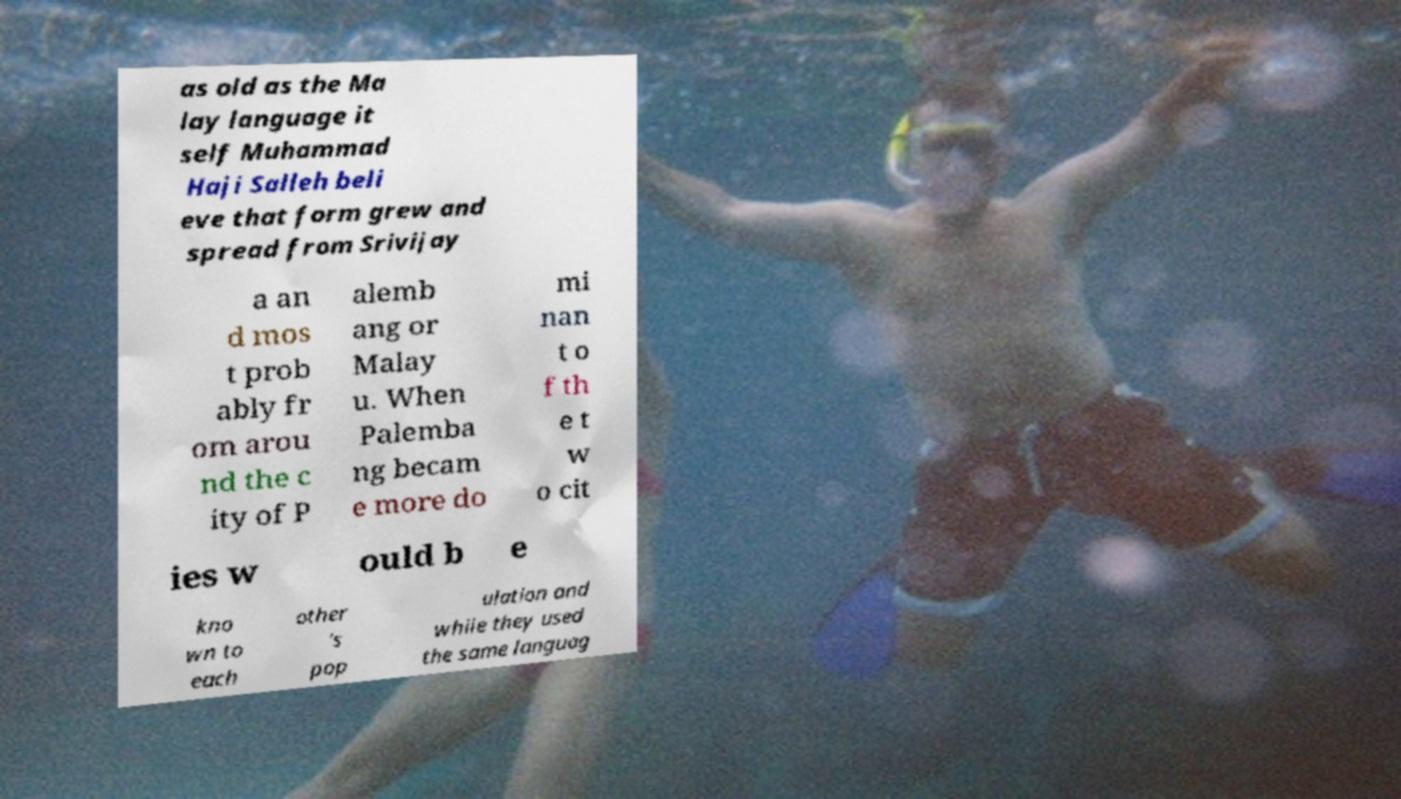Please read and relay the text visible in this image. What does it say? as old as the Ma lay language it self Muhammad Haji Salleh beli eve that form grew and spread from Srivijay a an d mos t prob ably fr om arou nd the c ity of P alemb ang or Malay u. When Palemba ng becam e more do mi nan t o f th e t w o cit ies w ould b e kno wn to each other 's pop ulation and while they used the same languag 